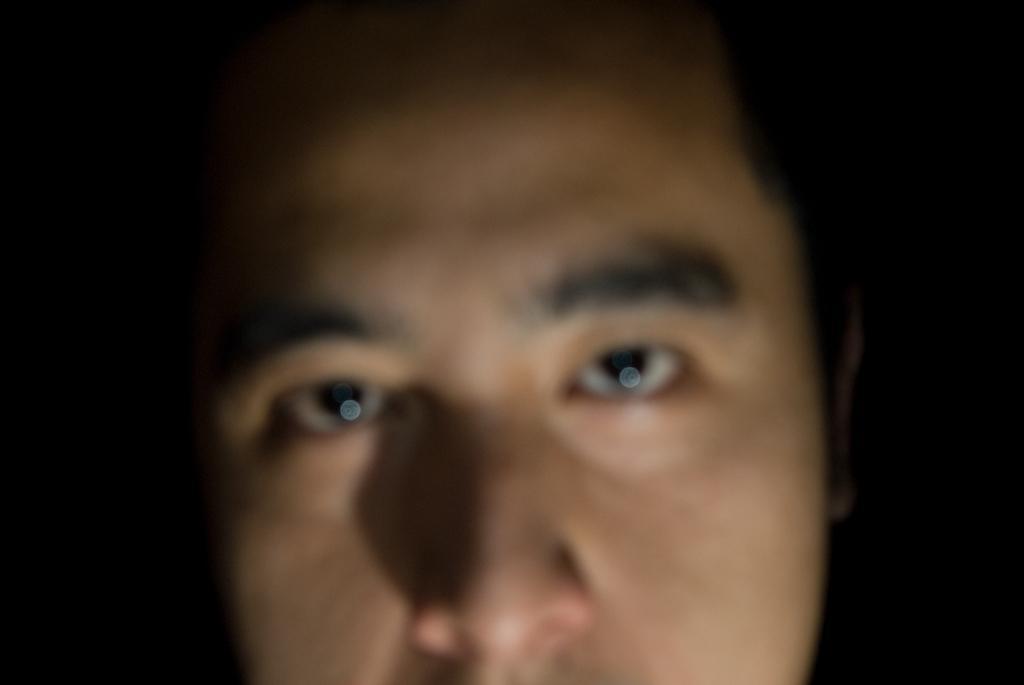Please provide a concise description of this image. In this image we can see face of a person. There is a dark background. 